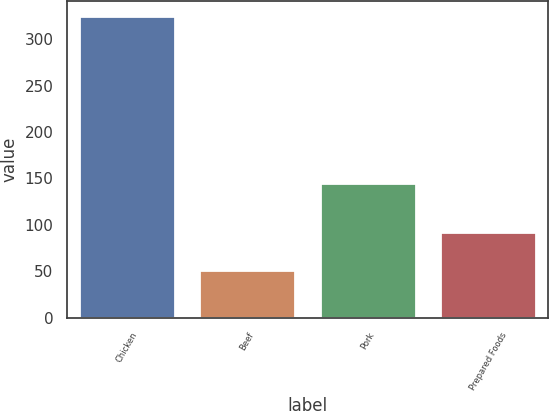Convert chart to OTSL. <chart><loc_0><loc_0><loc_500><loc_500><bar_chart><fcel>Chicken<fcel>Beef<fcel>Pork<fcel>Prepared Foods<nl><fcel>325<fcel>51<fcel>145<fcel>92<nl></chart> 